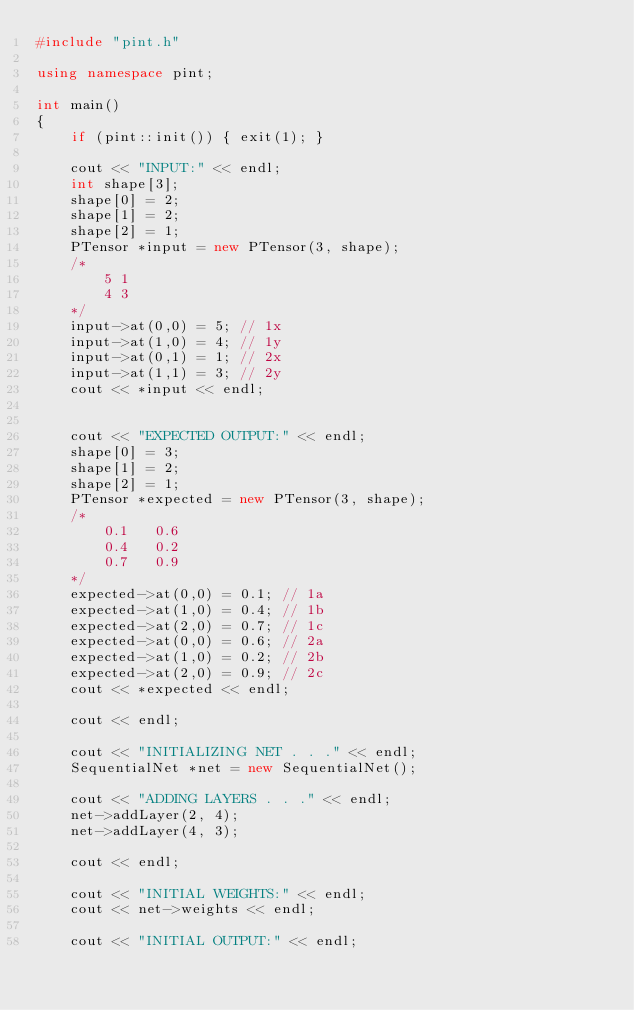<code> <loc_0><loc_0><loc_500><loc_500><_C++_>#include "pint.h"

using namespace pint;

int main()
{
    if (pint::init()) { exit(1); }

    cout << "INPUT:" << endl;
    int shape[3];
    shape[0] = 2;
    shape[1] = 2;
    shape[2] = 1;
    PTensor *input = new PTensor(3, shape);
    /*
        5 1
        4 3
    */
    input->at(0,0) = 5; // 1x
    input->at(1,0) = 4; // 1y
    input->at(0,1) = 1; // 2x
    input->at(1,1) = 3; // 2y
    cout << *input << endl;


    cout << "EXPECTED OUTPUT:" << endl;
    shape[0] = 3;
    shape[1] = 2;
    shape[2] = 1;
    PTensor *expected = new PTensor(3, shape);
    /*
        0.1   0.6
        0.4   0.2
        0.7   0.9
    */
    expected->at(0,0) = 0.1; // 1a
    expected->at(1,0) = 0.4; // 1b
    expected->at(2,0) = 0.7; // 1c
    expected->at(0,0) = 0.6; // 2a
    expected->at(1,0) = 0.2; // 2b
    expected->at(2,0) = 0.9; // 2c
    cout << *expected << endl;

    cout << endl;

    cout << "INITIALIZING NET . . ." << endl;
    SequentialNet *net = new SequentialNet();

    cout << "ADDING LAYERS . . ." << endl;
    net->addLayer(2, 4);
    net->addLayer(4, 3);

    cout << endl;

    cout << "INITIAL WEIGHTS:" << endl;
    cout << net->weights << endl;

    cout << "INITIAL OUTPUT:" << endl;</code> 